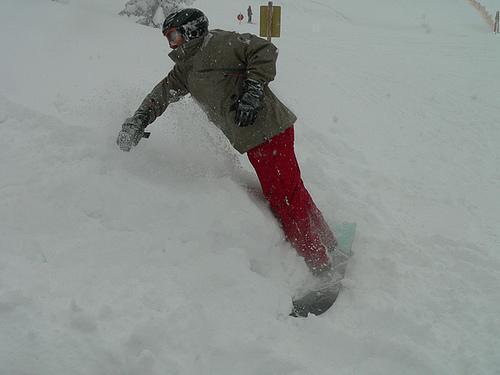How many bowls have food in them?
Give a very brief answer. 0. 